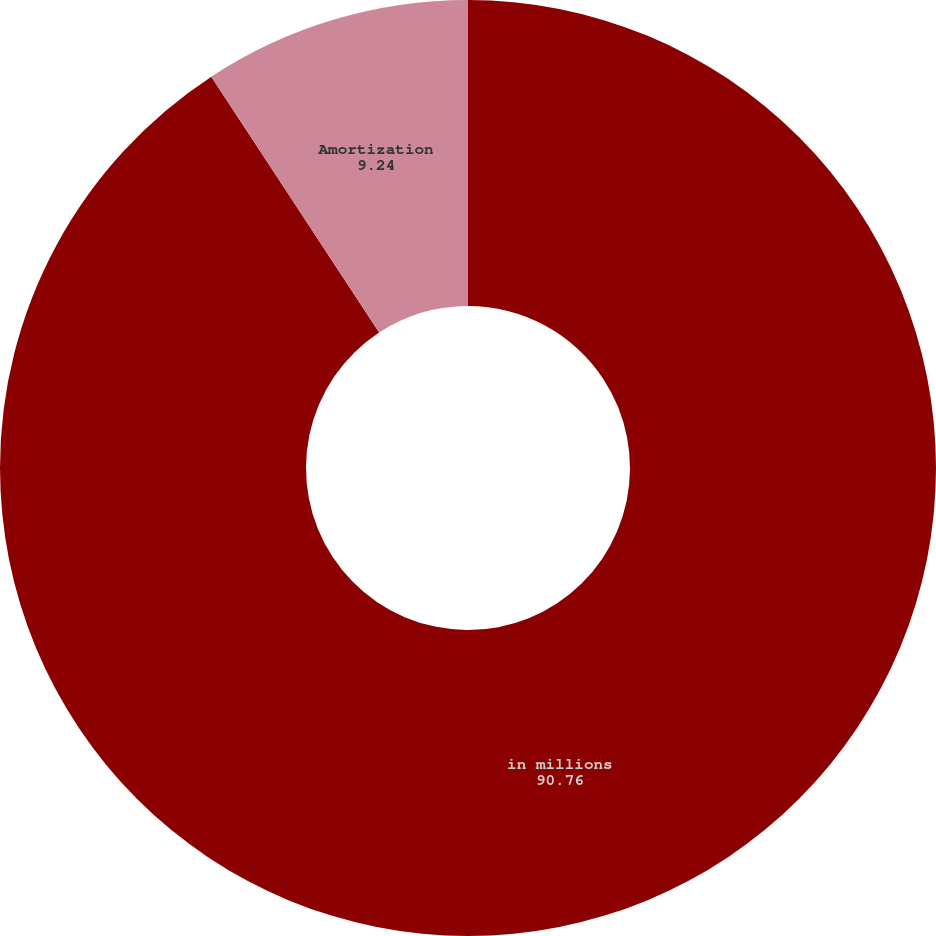Convert chart to OTSL. <chart><loc_0><loc_0><loc_500><loc_500><pie_chart><fcel>in millions<fcel>Amortization<nl><fcel>90.76%<fcel>9.24%<nl></chart> 